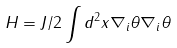<formula> <loc_0><loc_0><loc_500><loc_500>H = J / 2 \int d ^ { 2 } x \nabla _ { i } \theta \nabla _ { i } \theta</formula> 